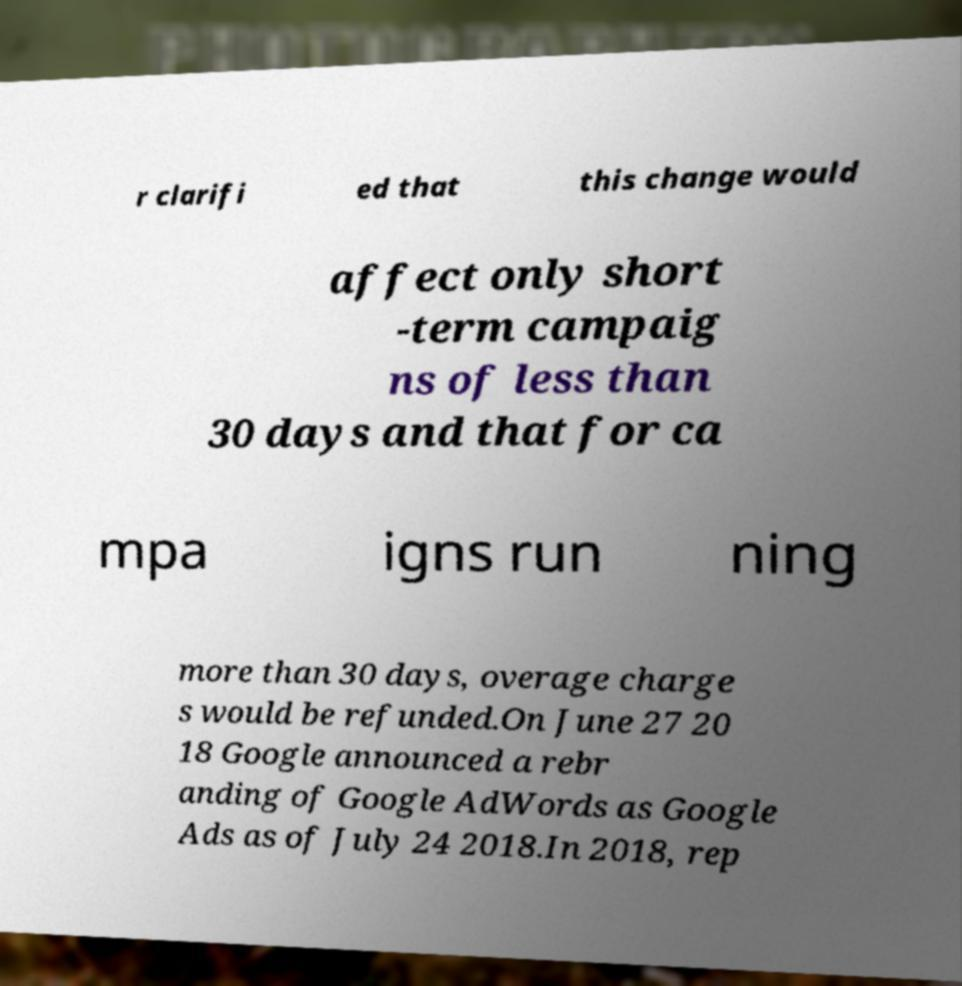Can you accurately transcribe the text from the provided image for me? r clarifi ed that this change would affect only short -term campaig ns of less than 30 days and that for ca mpa igns run ning more than 30 days, overage charge s would be refunded.On June 27 20 18 Google announced a rebr anding of Google AdWords as Google Ads as of July 24 2018.In 2018, rep 